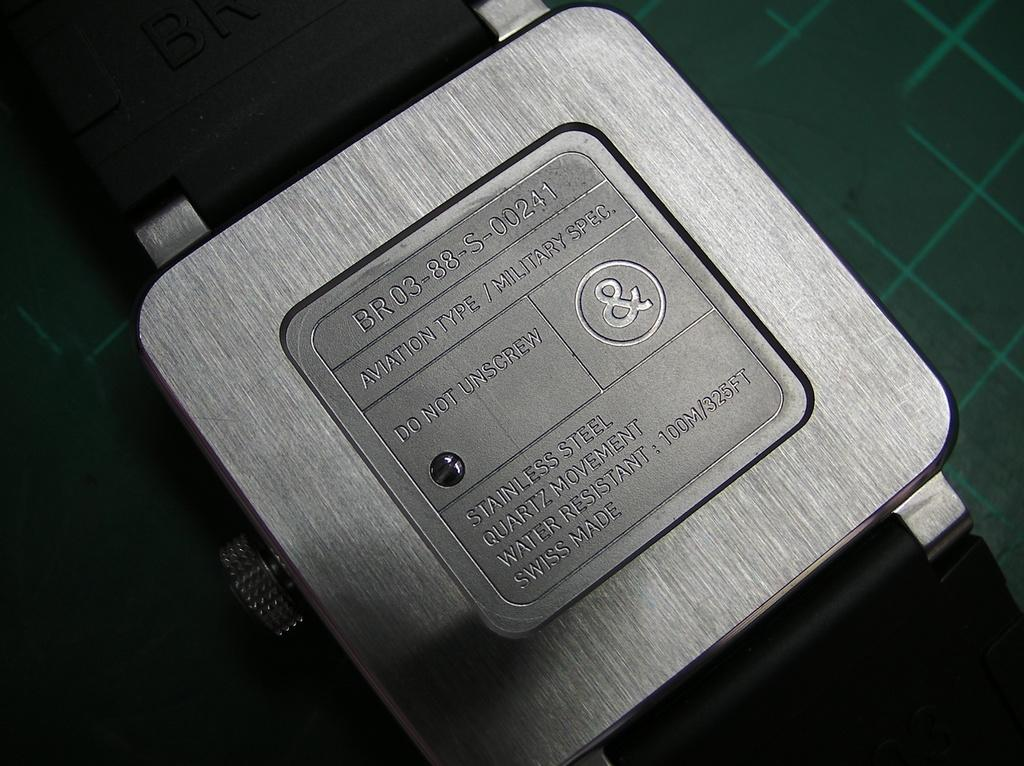Provide a one-sentence caption for the provided image. back of a stainless steel watch with a warning not to unscrew the screw. 